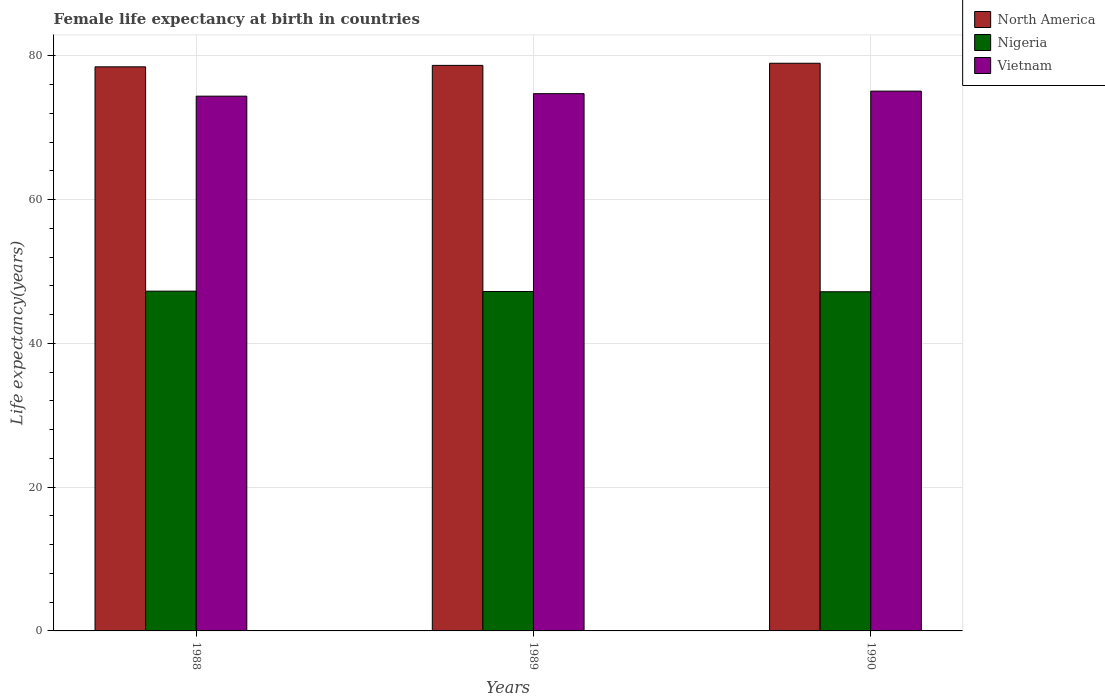How many bars are there on the 2nd tick from the left?
Offer a very short reply. 3. How many bars are there on the 1st tick from the right?
Ensure brevity in your answer.  3. What is the female life expectancy at birth in North America in 1989?
Ensure brevity in your answer.  78.69. Across all years, what is the maximum female life expectancy at birth in North America?
Your answer should be compact. 78.98. Across all years, what is the minimum female life expectancy at birth in North America?
Ensure brevity in your answer.  78.49. What is the total female life expectancy at birth in Nigeria in the graph?
Ensure brevity in your answer.  141.69. What is the difference between the female life expectancy at birth in Nigeria in 1988 and that in 1990?
Make the answer very short. 0.08. What is the difference between the female life expectancy at birth in North America in 1989 and the female life expectancy at birth in Nigeria in 1990?
Ensure brevity in your answer.  31.5. What is the average female life expectancy at birth in North America per year?
Provide a short and direct response. 78.72. In the year 1988, what is the difference between the female life expectancy at birth in Vietnam and female life expectancy at birth in Nigeria?
Ensure brevity in your answer.  27.13. In how many years, is the female life expectancy at birth in North America greater than 48 years?
Make the answer very short. 3. What is the ratio of the female life expectancy at birth in Vietnam in 1988 to that in 1989?
Provide a short and direct response. 1. Is the female life expectancy at birth in Vietnam in 1989 less than that in 1990?
Your answer should be compact. Yes. Is the difference between the female life expectancy at birth in Vietnam in 1988 and 1989 greater than the difference between the female life expectancy at birth in Nigeria in 1988 and 1989?
Offer a terse response. No. What is the difference between the highest and the second highest female life expectancy at birth in Nigeria?
Give a very brief answer. 0.05. What is the difference between the highest and the lowest female life expectancy at birth in North America?
Keep it short and to the point. 0.5. In how many years, is the female life expectancy at birth in Nigeria greater than the average female life expectancy at birth in Nigeria taken over all years?
Provide a short and direct response. 1. What does the 2nd bar from the left in 1990 represents?
Your response must be concise. Nigeria. Are all the bars in the graph horizontal?
Offer a very short reply. No. What is the difference between two consecutive major ticks on the Y-axis?
Offer a terse response. 20. Does the graph contain grids?
Give a very brief answer. Yes. Where does the legend appear in the graph?
Provide a short and direct response. Top right. How many legend labels are there?
Provide a short and direct response. 3. What is the title of the graph?
Offer a very short reply. Female life expectancy at birth in countries. Does "Timor-Leste" appear as one of the legend labels in the graph?
Your answer should be compact. No. What is the label or title of the X-axis?
Your response must be concise. Years. What is the label or title of the Y-axis?
Keep it short and to the point. Life expectancy(years). What is the Life expectancy(years) in North America in 1988?
Offer a very short reply. 78.49. What is the Life expectancy(years) of Nigeria in 1988?
Your answer should be compact. 47.27. What is the Life expectancy(years) of Vietnam in 1988?
Keep it short and to the point. 74.41. What is the Life expectancy(years) in North America in 1989?
Offer a very short reply. 78.69. What is the Life expectancy(years) of Nigeria in 1989?
Your answer should be compact. 47.23. What is the Life expectancy(years) in Vietnam in 1989?
Provide a succinct answer. 74.75. What is the Life expectancy(years) of North America in 1990?
Your answer should be very brief. 78.98. What is the Life expectancy(years) of Nigeria in 1990?
Provide a short and direct response. 47.19. What is the Life expectancy(years) of Vietnam in 1990?
Provide a short and direct response. 75.11. Across all years, what is the maximum Life expectancy(years) of North America?
Offer a very short reply. 78.98. Across all years, what is the maximum Life expectancy(years) in Nigeria?
Give a very brief answer. 47.27. Across all years, what is the maximum Life expectancy(years) of Vietnam?
Your answer should be very brief. 75.11. Across all years, what is the minimum Life expectancy(years) of North America?
Keep it short and to the point. 78.49. Across all years, what is the minimum Life expectancy(years) of Nigeria?
Provide a succinct answer. 47.19. Across all years, what is the minimum Life expectancy(years) in Vietnam?
Provide a succinct answer. 74.41. What is the total Life expectancy(years) in North America in the graph?
Make the answer very short. 236.16. What is the total Life expectancy(years) in Nigeria in the graph?
Give a very brief answer. 141.69. What is the total Life expectancy(years) in Vietnam in the graph?
Provide a succinct answer. 224.26. What is the difference between the Life expectancy(years) of North America in 1988 and that in 1989?
Keep it short and to the point. -0.2. What is the difference between the Life expectancy(years) in Nigeria in 1988 and that in 1989?
Provide a succinct answer. 0.05. What is the difference between the Life expectancy(years) in Vietnam in 1988 and that in 1989?
Offer a terse response. -0.35. What is the difference between the Life expectancy(years) of North America in 1988 and that in 1990?
Offer a very short reply. -0.5. What is the difference between the Life expectancy(years) of Nigeria in 1988 and that in 1990?
Your answer should be compact. 0.08. What is the difference between the Life expectancy(years) in Vietnam in 1988 and that in 1990?
Offer a very short reply. -0.7. What is the difference between the Life expectancy(years) in North America in 1989 and that in 1990?
Keep it short and to the point. -0.3. What is the difference between the Life expectancy(years) in Nigeria in 1989 and that in 1990?
Give a very brief answer. 0.04. What is the difference between the Life expectancy(years) of Vietnam in 1989 and that in 1990?
Make the answer very short. -0.35. What is the difference between the Life expectancy(years) in North America in 1988 and the Life expectancy(years) in Nigeria in 1989?
Your answer should be very brief. 31.26. What is the difference between the Life expectancy(years) in North America in 1988 and the Life expectancy(years) in Vietnam in 1989?
Provide a short and direct response. 3.73. What is the difference between the Life expectancy(years) of Nigeria in 1988 and the Life expectancy(years) of Vietnam in 1989?
Your answer should be compact. -27.48. What is the difference between the Life expectancy(years) of North America in 1988 and the Life expectancy(years) of Nigeria in 1990?
Keep it short and to the point. 31.3. What is the difference between the Life expectancy(years) in North America in 1988 and the Life expectancy(years) in Vietnam in 1990?
Give a very brief answer. 3.38. What is the difference between the Life expectancy(years) of Nigeria in 1988 and the Life expectancy(years) of Vietnam in 1990?
Your answer should be compact. -27.83. What is the difference between the Life expectancy(years) of North America in 1989 and the Life expectancy(years) of Nigeria in 1990?
Your answer should be compact. 31.5. What is the difference between the Life expectancy(years) in North America in 1989 and the Life expectancy(years) in Vietnam in 1990?
Offer a very short reply. 3.58. What is the difference between the Life expectancy(years) in Nigeria in 1989 and the Life expectancy(years) in Vietnam in 1990?
Provide a succinct answer. -27.88. What is the average Life expectancy(years) in North America per year?
Your answer should be compact. 78.72. What is the average Life expectancy(years) of Nigeria per year?
Offer a very short reply. 47.23. What is the average Life expectancy(years) in Vietnam per year?
Your answer should be very brief. 74.75. In the year 1988, what is the difference between the Life expectancy(years) in North America and Life expectancy(years) in Nigeria?
Give a very brief answer. 31.21. In the year 1988, what is the difference between the Life expectancy(years) in North America and Life expectancy(years) in Vietnam?
Provide a succinct answer. 4.08. In the year 1988, what is the difference between the Life expectancy(years) of Nigeria and Life expectancy(years) of Vietnam?
Your response must be concise. -27.13. In the year 1989, what is the difference between the Life expectancy(years) in North America and Life expectancy(years) in Nigeria?
Your answer should be compact. 31.46. In the year 1989, what is the difference between the Life expectancy(years) of North America and Life expectancy(years) of Vietnam?
Keep it short and to the point. 3.93. In the year 1989, what is the difference between the Life expectancy(years) of Nigeria and Life expectancy(years) of Vietnam?
Give a very brief answer. -27.52. In the year 1990, what is the difference between the Life expectancy(years) of North America and Life expectancy(years) of Nigeria?
Offer a terse response. 31.79. In the year 1990, what is the difference between the Life expectancy(years) in North America and Life expectancy(years) in Vietnam?
Provide a short and direct response. 3.88. In the year 1990, what is the difference between the Life expectancy(years) of Nigeria and Life expectancy(years) of Vietnam?
Provide a short and direct response. -27.91. What is the ratio of the Life expectancy(years) in North America in 1988 to that in 1989?
Give a very brief answer. 1. What is the ratio of the Life expectancy(years) of Vietnam in 1988 to that in 1989?
Your answer should be compact. 1. What is the ratio of the Life expectancy(years) in Vietnam in 1988 to that in 1990?
Keep it short and to the point. 0.99. What is the ratio of the Life expectancy(years) of Vietnam in 1989 to that in 1990?
Provide a succinct answer. 1. What is the difference between the highest and the second highest Life expectancy(years) in North America?
Keep it short and to the point. 0.3. What is the difference between the highest and the second highest Life expectancy(years) of Nigeria?
Your response must be concise. 0.05. What is the difference between the highest and the second highest Life expectancy(years) in Vietnam?
Make the answer very short. 0.35. What is the difference between the highest and the lowest Life expectancy(years) of North America?
Ensure brevity in your answer.  0.5. What is the difference between the highest and the lowest Life expectancy(years) in Nigeria?
Provide a short and direct response. 0.08. What is the difference between the highest and the lowest Life expectancy(years) of Vietnam?
Provide a succinct answer. 0.7. 